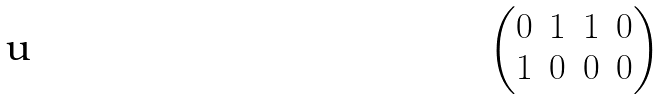<formula> <loc_0><loc_0><loc_500><loc_500>\begin{pmatrix} 0 & 1 & 1 & 0 \\ 1 & 0 & 0 & 0 \end{pmatrix}</formula> 